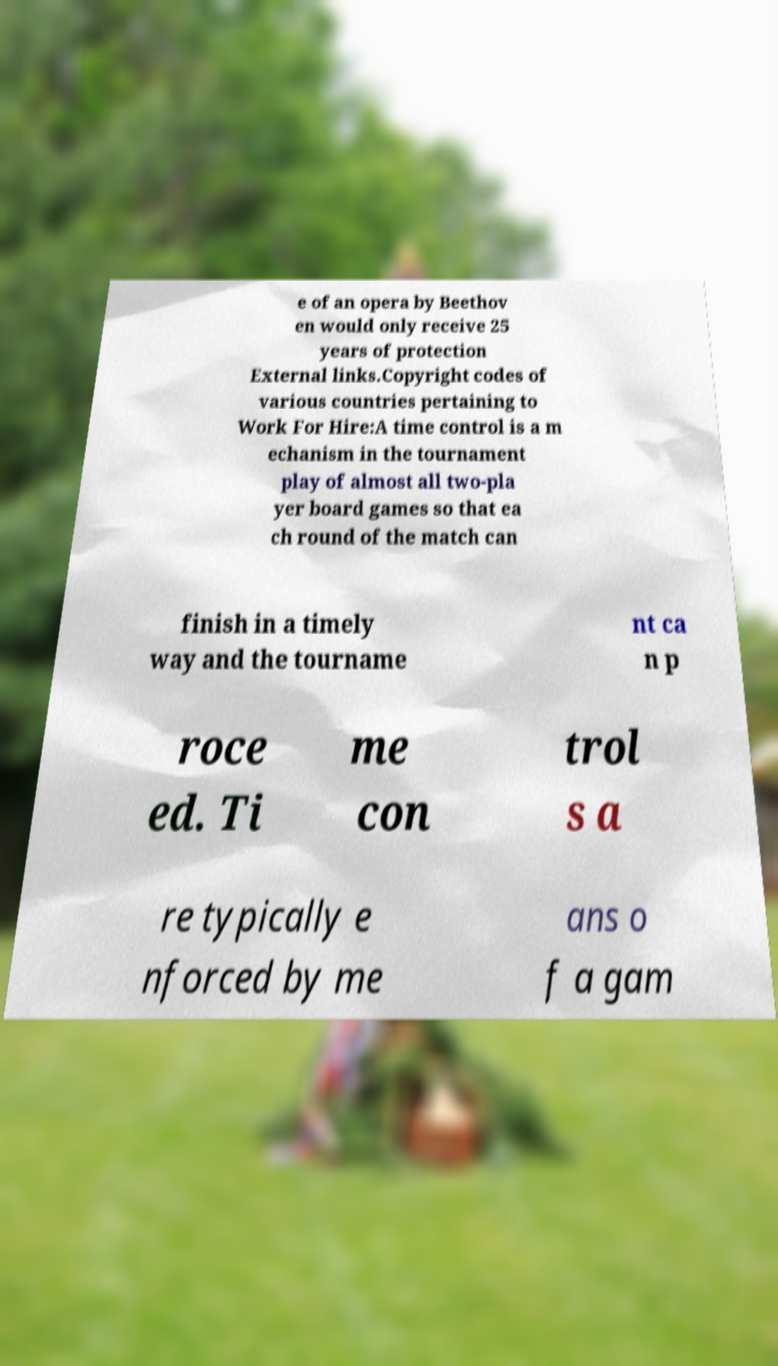What messages or text are displayed in this image? I need them in a readable, typed format. e of an opera by Beethov en would only receive 25 years of protection External links.Copyright codes of various countries pertaining to Work For Hire:A time control is a m echanism in the tournament play of almost all two-pla yer board games so that ea ch round of the match can finish in a timely way and the tourname nt ca n p roce ed. Ti me con trol s a re typically e nforced by me ans o f a gam 